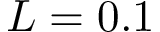Convert formula to latex. <formula><loc_0><loc_0><loc_500><loc_500>L = 0 . 1</formula> 